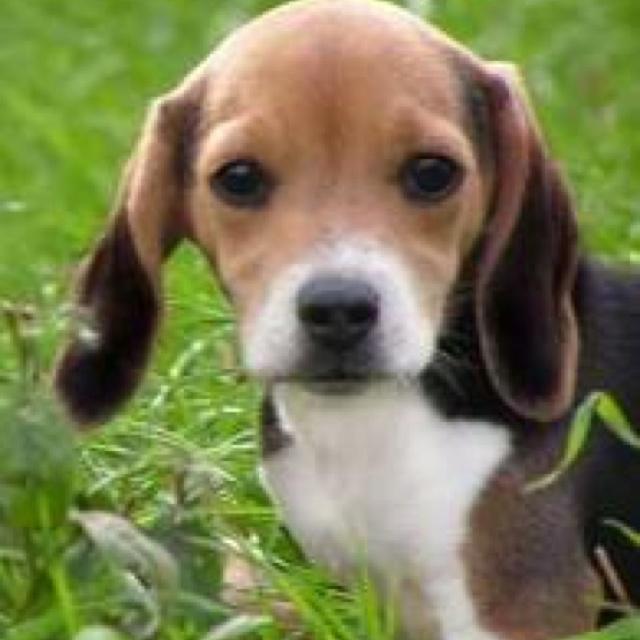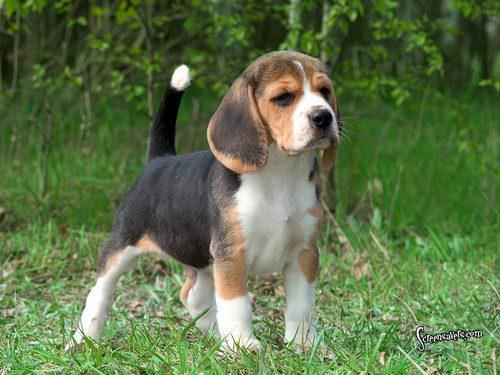The first image is the image on the left, the second image is the image on the right. Analyze the images presented: Is the assertion "beagles are sitting or standing in green grass" valid? Answer yes or no. Yes. The first image is the image on the left, the second image is the image on the right. For the images displayed, is the sentence "An image shows a dog looking up at the camera with a semi-circular shape under its nose." factually correct? Answer yes or no. No. 